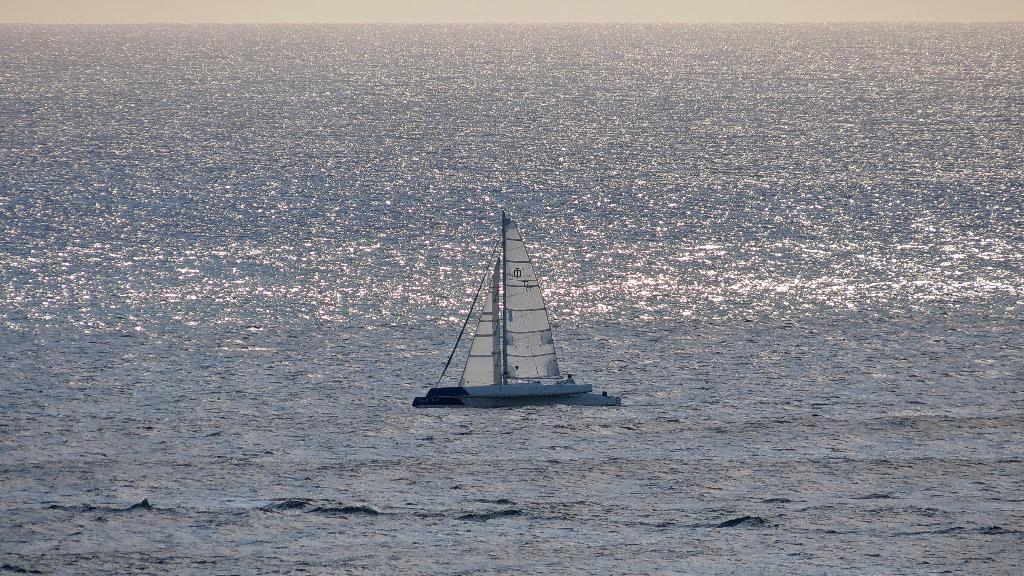What is the primary element visible in the image? There is water in the image. What is located on the water? There is a boat on the water. Where is the crowd gathered in the image? There is no crowd present in the image; it only features water and a boat. What type of scarf is draped over the boat in the image? There is no scarf present in the image; it only features water and a boat. 